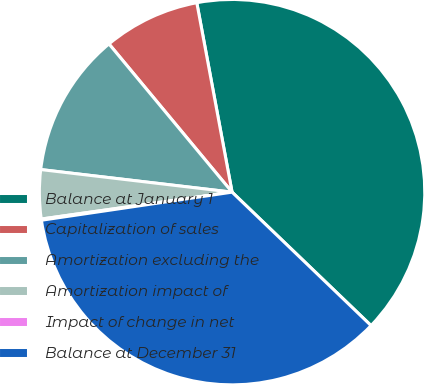<chart> <loc_0><loc_0><loc_500><loc_500><pie_chart><fcel>Balance at January 1<fcel>Capitalization of sales<fcel>Amortization excluding the<fcel>Amortization impact of<fcel>Impact of change in net<fcel>Balance at December 31<nl><fcel>40.11%<fcel>8.1%<fcel>12.1%<fcel>4.1%<fcel>0.1%<fcel>35.5%<nl></chart> 